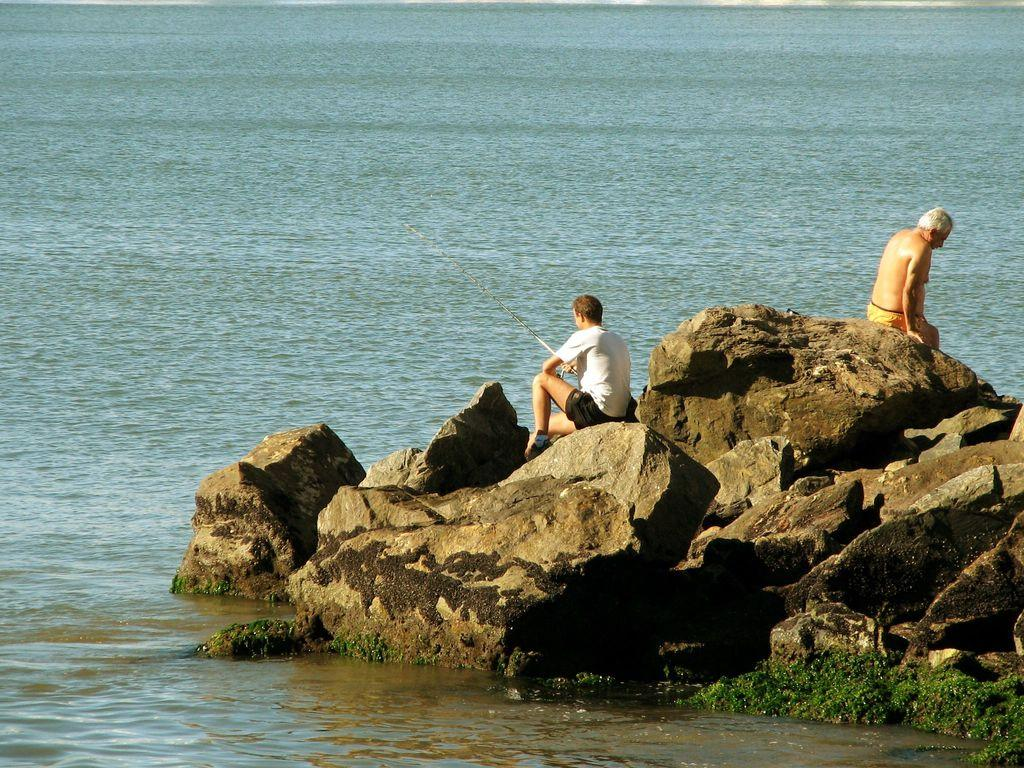What is located in the center of the image? There are rocks in the center of the image. What are the rocks being used for in the image? Two persons are sitting on the rocks. What can be seen at the bottom of the image? There is a river at the bottom of the image. What type of paper is being used to create trouble in the image? There is no paper or indication of trouble in the image; it features rocks, two persons sitting on them, and a river. 